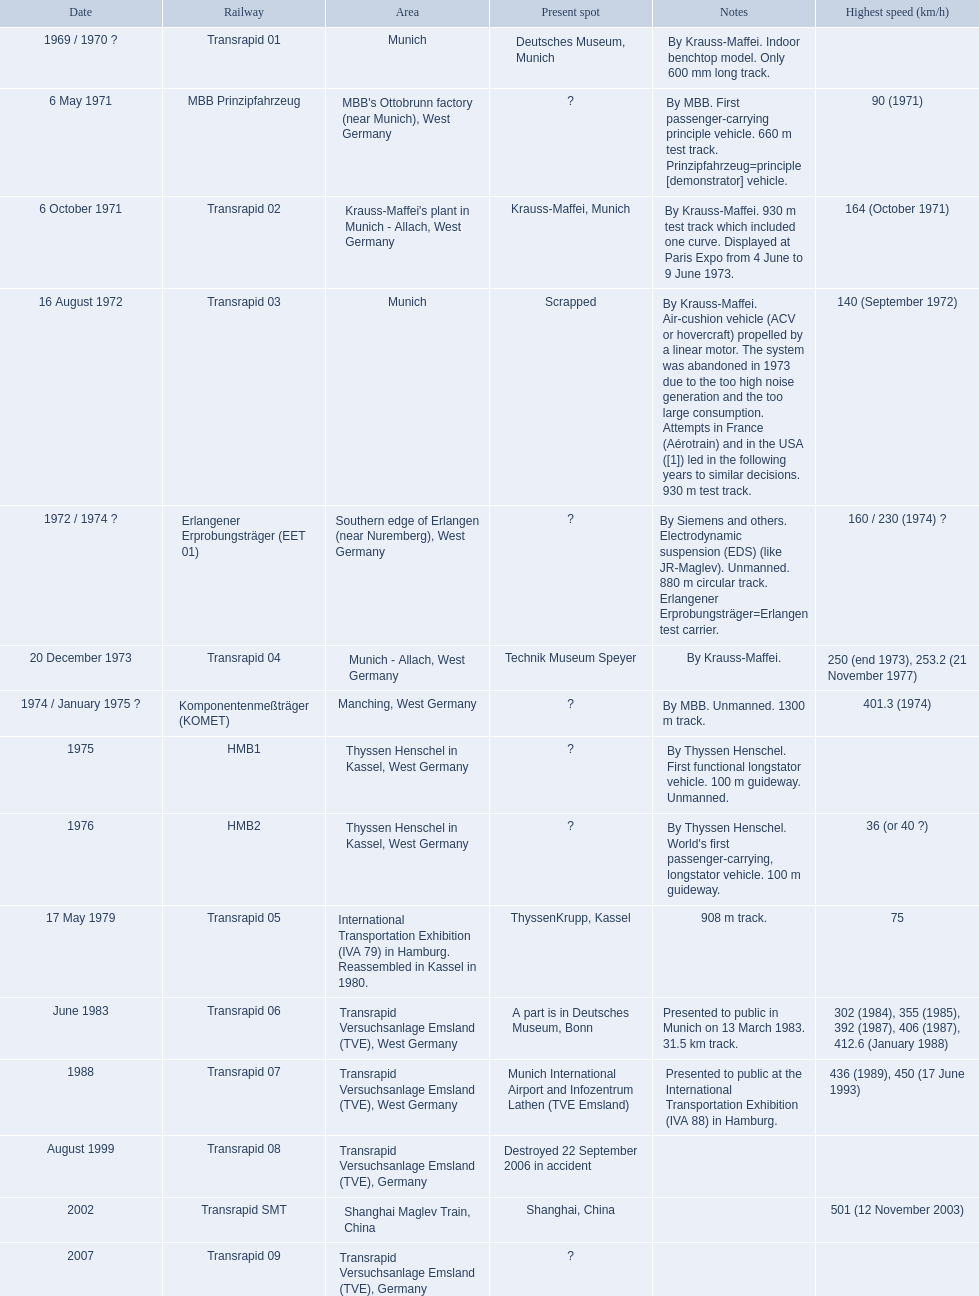What is the top speed reached by any trains shown here? 501 (12 November 2003). What train has reached a top speed of 501? Transrapid SMT. 